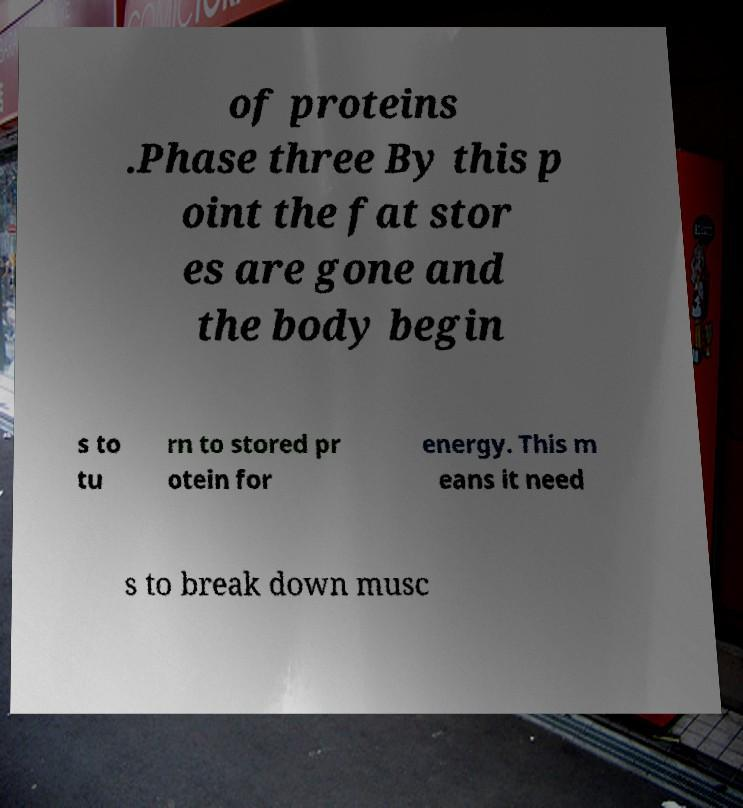Can you read and provide the text displayed in the image?This photo seems to have some interesting text. Can you extract and type it out for me? of proteins .Phase three By this p oint the fat stor es are gone and the body begin s to tu rn to stored pr otein for energy. This m eans it need s to break down musc 